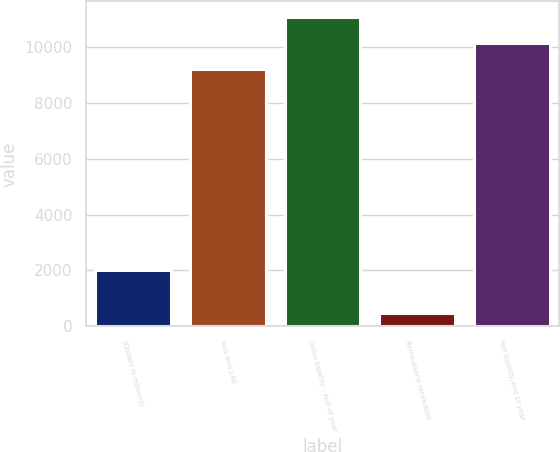<chart> <loc_0><loc_0><loc_500><loc_500><bar_chart><fcel>(Dollars in millions)<fcel>loss and LAE<fcel>Gross liability - end of year<fcel>Reinsurance receivable<fcel>Net liability-end of year<nl><fcel>2013<fcel>9235.3<fcel>11082.4<fcel>474<fcel>10158.8<nl></chart> 